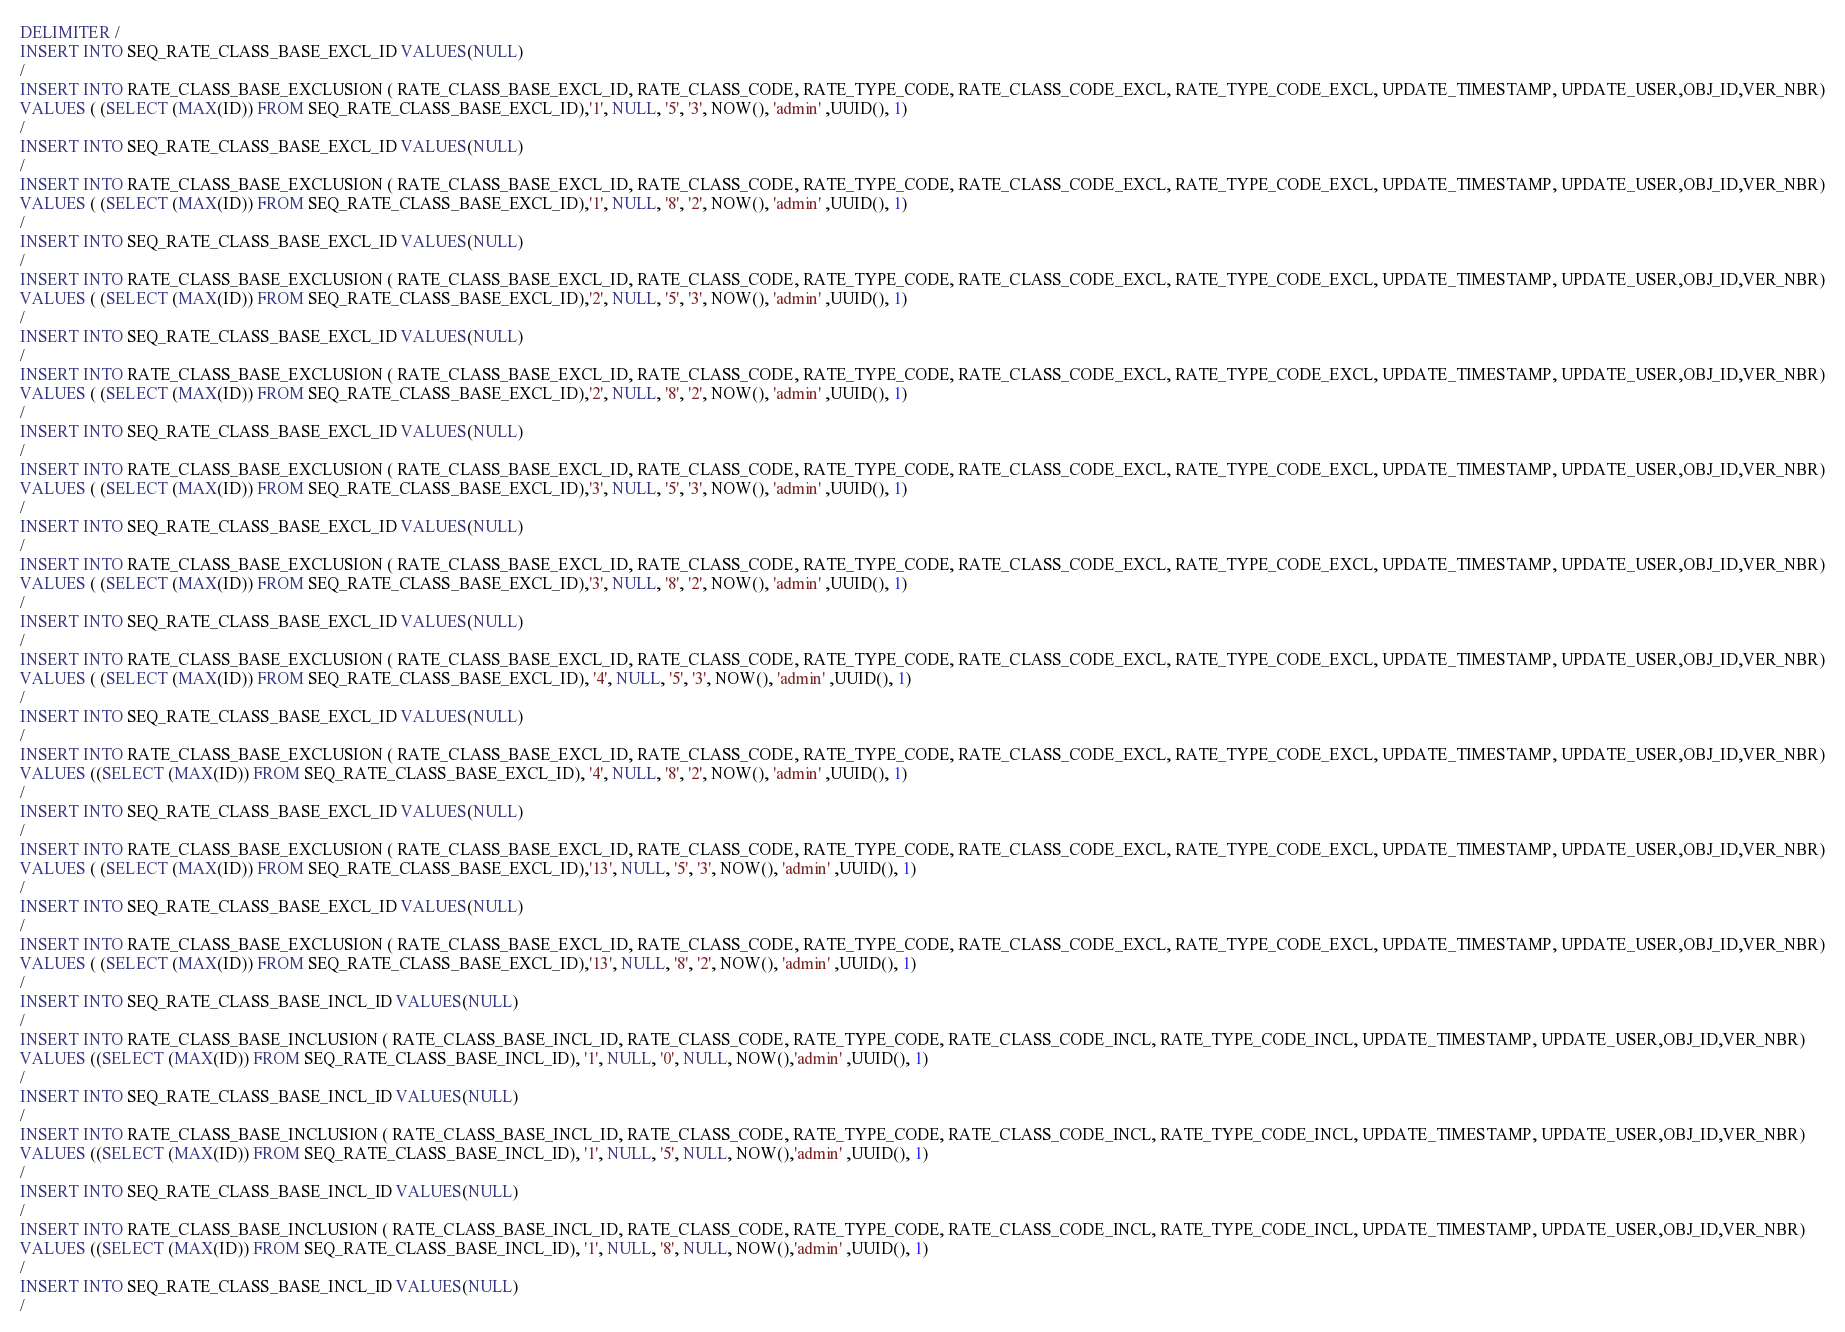Convert code to text. <code><loc_0><loc_0><loc_500><loc_500><_SQL_>DELIMITER /
INSERT INTO SEQ_RATE_CLASS_BASE_EXCL_ID VALUES(NULL)
/
INSERT INTO RATE_CLASS_BASE_EXCLUSION ( RATE_CLASS_BASE_EXCL_ID, RATE_CLASS_CODE, RATE_TYPE_CODE, RATE_CLASS_CODE_EXCL, RATE_TYPE_CODE_EXCL, UPDATE_TIMESTAMP, UPDATE_USER,OBJ_ID,VER_NBR)
VALUES ( (SELECT (MAX(ID)) FROM SEQ_RATE_CLASS_BASE_EXCL_ID),'1', NULL, '5', '3', NOW(), 'admin' ,UUID(), 1)
/
INSERT INTO SEQ_RATE_CLASS_BASE_EXCL_ID VALUES(NULL)
/
INSERT INTO RATE_CLASS_BASE_EXCLUSION ( RATE_CLASS_BASE_EXCL_ID, RATE_CLASS_CODE, RATE_TYPE_CODE, RATE_CLASS_CODE_EXCL, RATE_TYPE_CODE_EXCL, UPDATE_TIMESTAMP, UPDATE_USER,OBJ_ID,VER_NBR)
VALUES ( (SELECT (MAX(ID)) FROM SEQ_RATE_CLASS_BASE_EXCL_ID),'1', NULL, '8', '2', NOW(), 'admin' ,UUID(), 1)
/
INSERT INTO SEQ_RATE_CLASS_BASE_EXCL_ID VALUES(NULL)
/
INSERT INTO RATE_CLASS_BASE_EXCLUSION ( RATE_CLASS_BASE_EXCL_ID, RATE_CLASS_CODE, RATE_TYPE_CODE, RATE_CLASS_CODE_EXCL, RATE_TYPE_CODE_EXCL, UPDATE_TIMESTAMP, UPDATE_USER,OBJ_ID,VER_NBR)
VALUES ( (SELECT (MAX(ID)) FROM SEQ_RATE_CLASS_BASE_EXCL_ID),'2', NULL, '5', '3', NOW(), 'admin' ,UUID(), 1)
/
INSERT INTO SEQ_RATE_CLASS_BASE_EXCL_ID VALUES(NULL)
/
INSERT INTO RATE_CLASS_BASE_EXCLUSION ( RATE_CLASS_BASE_EXCL_ID, RATE_CLASS_CODE, RATE_TYPE_CODE, RATE_CLASS_CODE_EXCL, RATE_TYPE_CODE_EXCL, UPDATE_TIMESTAMP, UPDATE_USER,OBJ_ID,VER_NBR)
VALUES ( (SELECT (MAX(ID)) FROM SEQ_RATE_CLASS_BASE_EXCL_ID),'2', NULL, '8', '2', NOW(), 'admin' ,UUID(), 1)
/
INSERT INTO SEQ_RATE_CLASS_BASE_EXCL_ID VALUES(NULL)
/
INSERT INTO RATE_CLASS_BASE_EXCLUSION ( RATE_CLASS_BASE_EXCL_ID, RATE_CLASS_CODE, RATE_TYPE_CODE, RATE_CLASS_CODE_EXCL, RATE_TYPE_CODE_EXCL, UPDATE_TIMESTAMP, UPDATE_USER,OBJ_ID,VER_NBR)
VALUES ( (SELECT (MAX(ID)) FROM SEQ_RATE_CLASS_BASE_EXCL_ID),'3', NULL, '5', '3', NOW(), 'admin' ,UUID(), 1)
/
INSERT INTO SEQ_RATE_CLASS_BASE_EXCL_ID VALUES(NULL)
/
INSERT INTO RATE_CLASS_BASE_EXCLUSION ( RATE_CLASS_BASE_EXCL_ID, RATE_CLASS_CODE, RATE_TYPE_CODE, RATE_CLASS_CODE_EXCL, RATE_TYPE_CODE_EXCL, UPDATE_TIMESTAMP, UPDATE_USER,OBJ_ID,VER_NBR)
VALUES ( (SELECT (MAX(ID)) FROM SEQ_RATE_CLASS_BASE_EXCL_ID),'3', NULL, '8', '2', NOW(), 'admin' ,UUID(), 1)
/
INSERT INTO SEQ_RATE_CLASS_BASE_EXCL_ID VALUES(NULL)
/
INSERT INTO RATE_CLASS_BASE_EXCLUSION ( RATE_CLASS_BASE_EXCL_ID, RATE_CLASS_CODE, RATE_TYPE_CODE, RATE_CLASS_CODE_EXCL, RATE_TYPE_CODE_EXCL, UPDATE_TIMESTAMP, UPDATE_USER,OBJ_ID,VER_NBR)
VALUES ( (SELECT (MAX(ID)) FROM SEQ_RATE_CLASS_BASE_EXCL_ID), '4', NULL, '5', '3', NOW(), 'admin' ,UUID(), 1)
/
INSERT INTO SEQ_RATE_CLASS_BASE_EXCL_ID VALUES(NULL)
/
INSERT INTO RATE_CLASS_BASE_EXCLUSION ( RATE_CLASS_BASE_EXCL_ID, RATE_CLASS_CODE, RATE_TYPE_CODE, RATE_CLASS_CODE_EXCL, RATE_TYPE_CODE_EXCL, UPDATE_TIMESTAMP, UPDATE_USER,OBJ_ID,VER_NBR)
VALUES ((SELECT (MAX(ID)) FROM SEQ_RATE_CLASS_BASE_EXCL_ID), '4', NULL, '8', '2', NOW(), 'admin' ,UUID(), 1)
/
INSERT INTO SEQ_RATE_CLASS_BASE_EXCL_ID VALUES(NULL)
/
INSERT INTO RATE_CLASS_BASE_EXCLUSION ( RATE_CLASS_BASE_EXCL_ID, RATE_CLASS_CODE, RATE_TYPE_CODE, RATE_CLASS_CODE_EXCL, RATE_TYPE_CODE_EXCL, UPDATE_TIMESTAMP, UPDATE_USER,OBJ_ID,VER_NBR)
VALUES ( (SELECT (MAX(ID)) FROM SEQ_RATE_CLASS_BASE_EXCL_ID),'13', NULL, '5', '3', NOW(), 'admin' ,UUID(), 1)
/
INSERT INTO SEQ_RATE_CLASS_BASE_EXCL_ID VALUES(NULL)
/
INSERT INTO RATE_CLASS_BASE_EXCLUSION ( RATE_CLASS_BASE_EXCL_ID, RATE_CLASS_CODE, RATE_TYPE_CODE, RATE_CLASS_CODE_EXCL, RATE_TYPE_CODE_EXCL, UPDATE_TIMESTAMP, UPDATE_USER,OBJ_ID,VER_NBR)
VALUES ( (SELECT (MAX(ID)) FROM SEQ_RATE_CLASS_BASE_EXCL_ID),'13', NULL, '8', '2', NOW(), 'admin' ,UUID(), 1)
/
INSERT INTO SEQ_RATE_CLASS_BASE_INCL_ID VALUES(NULL)
/
INSERT INTO RATE_CLASS_BASE_INCLUSION ( RATE_CLASS_BASE_INCL_ID, RATE_CLASS_CODE, RATE_TYPE_CODE, RATE_CLASS_CODE_INCL, RATE_TYPE_CODE_INCL, UPDATE_TIMESTAMP, UPDATE_USER,OBJ_ID,VER_NBR)
VALUES ((SELECT (MAX(ID)) FROM SEQ_RATE_CLASS_BASE_INCL_ID), '1', NULL, '0', NULL, NOW(),'admin' ,UUID(), 1)
/
INSERT INTO SEQ_RATE_CLASS_BASE_INCL_ID VALUES(NULL)
/
INSERT INTO RATE_CLASS_BASE_INCLUSION ( RATE_CLASS_BASE_INCL_ID, RATE_CLASS_CODE, RATE_TYPE_CODE, RATE_CLASS_CODE_INCL, RATE_TYPE_CODE_INCL, UPDATE_TIMESTAMP, UPDATE_USER,OBJ_ID,VER_NBR)
VALUES ((SELECT (MAX(ID)) FROM SEQ_RATE_CLASS_BASE_INCL_ID), '1', NULL, '5', NULL, NOW(),'admin' ,UUID(), 1)
/
INSERT INTO SEQ_RATE_CLASS_BASE_INCL_ID VALUES(NULL)
/
INSERT INTO RATE_CLASS_BASE_INCLUSION ( RATE_CLASS_BASE_INCL_ID, RATE_CLASS_CODE, RATE_TYPE_CODE, RATE_CLASS_CODE_INCL, RATE_TYPE_CODE_INCL, UPDATE_TIMESTAMP, UPDATE_USER,OBJ_ID,VER_NBR)
VALUES ((SELECT (MAX(ID)) FROM SEQ_RATE_CLASS_BASE_INCL_ID), '1', NULL, '8', NULL, NOW(),'admin' ,UUID(), 1)
/
INSERT INTO SEQ_RATE_CLASS_BASE_INCL_ID VALUES(NULL)
/</code> 